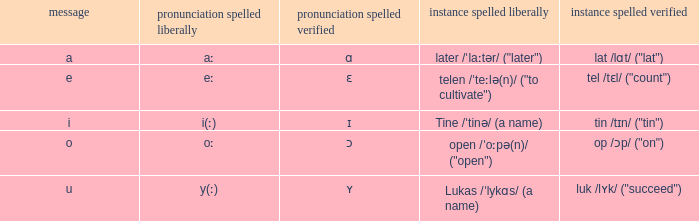What is Pronunciation Spelled Free, when Pronunciation Spelled Checked is "ɛ"? Eː. 